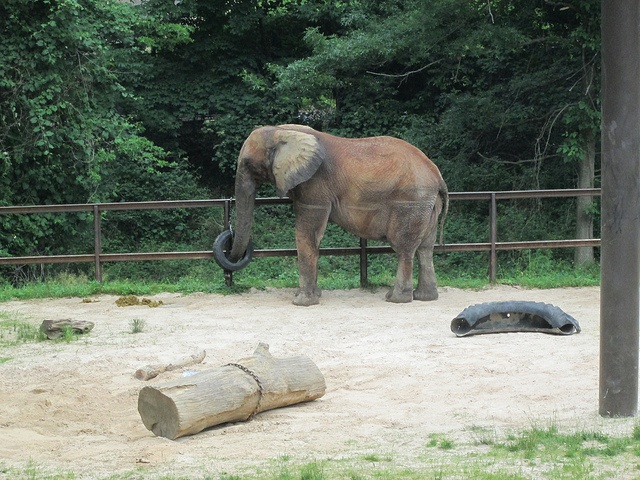Describe the objects in this image and their specific colors. I can see a elephant in black, gray, and darkgray tones in this image. 